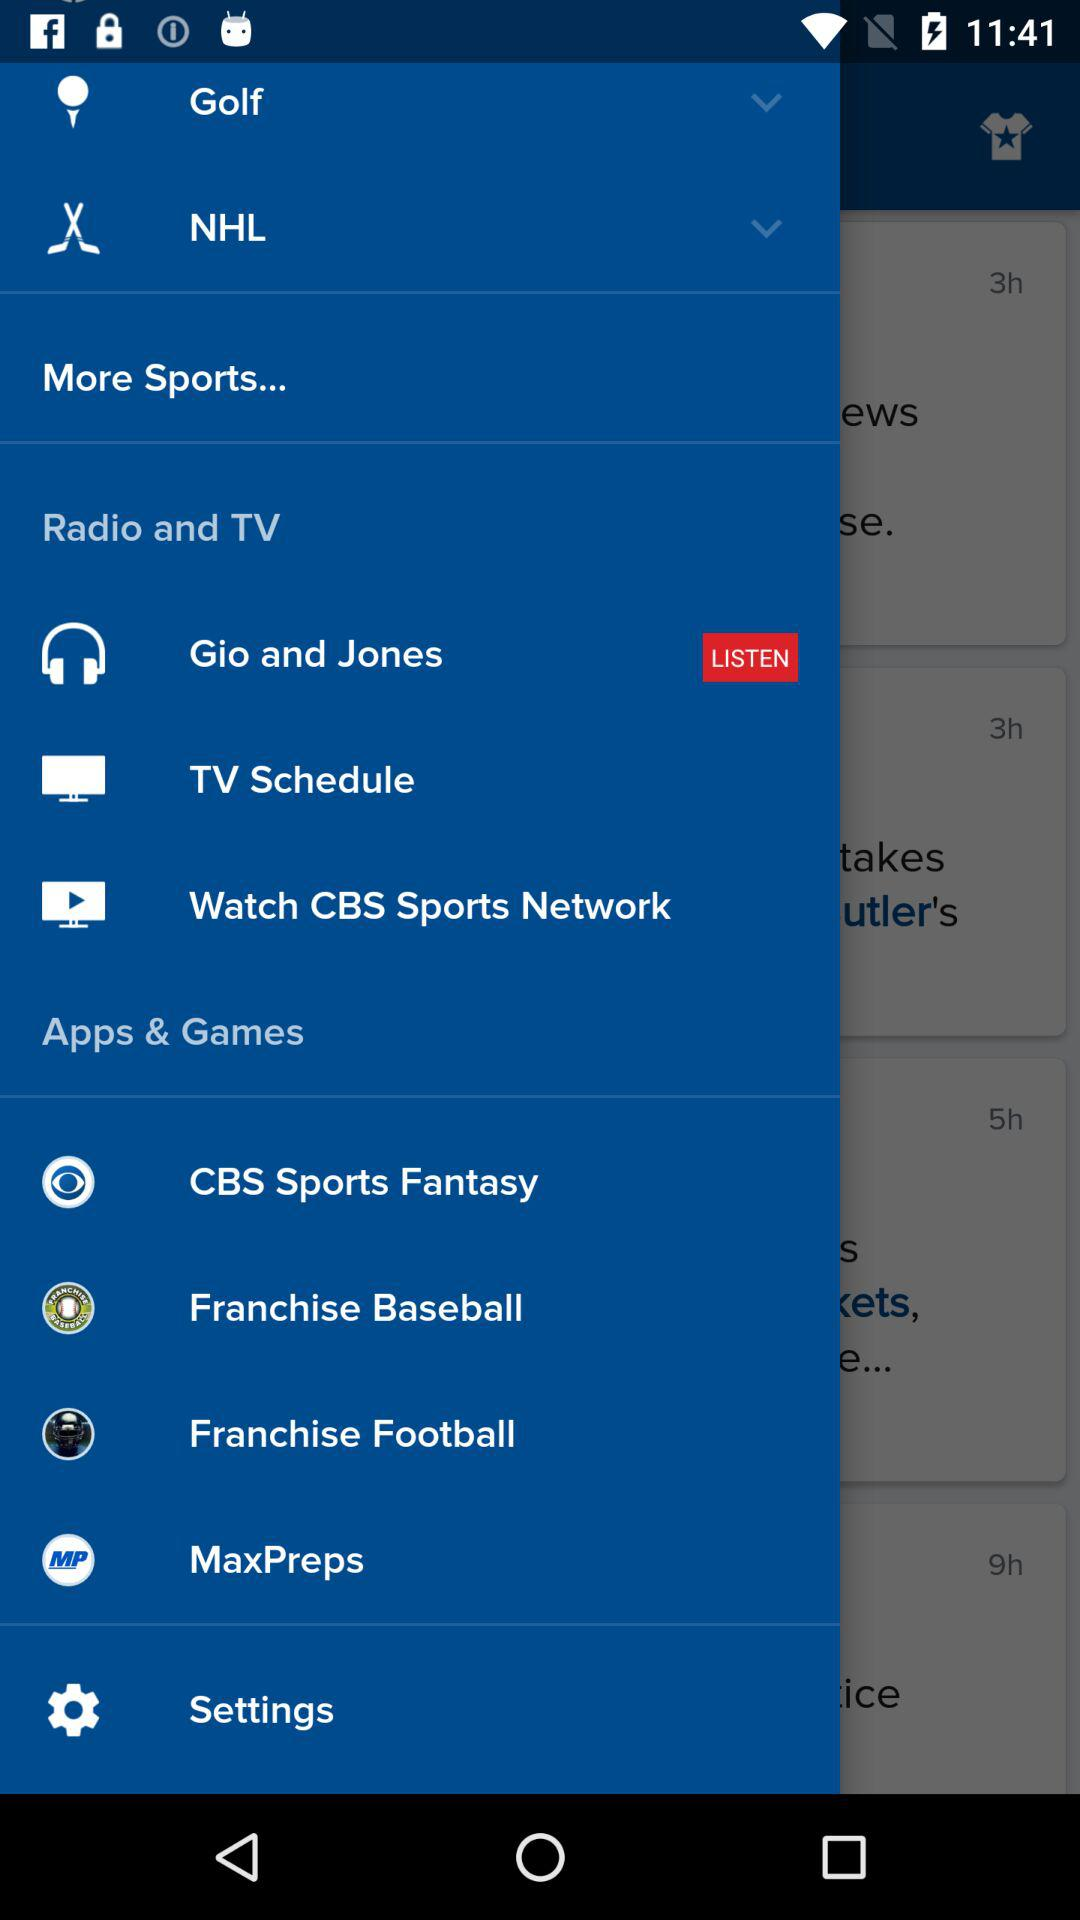How many items have a downward arrow next to them?
Answer the question using a single word or phrase. 2 